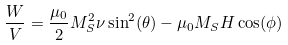<formula> <loc_0><loc_0><loc_500><loc_500>\frac { W } { V } = \frac { \mu _ { 0 } } { 2 } M _ { S } ^ { 2 } \nu \sin ^ { 2 } ( \theta ) - \mu _ { 0 } M _ { S } H \cos ( \phi )</formula> 